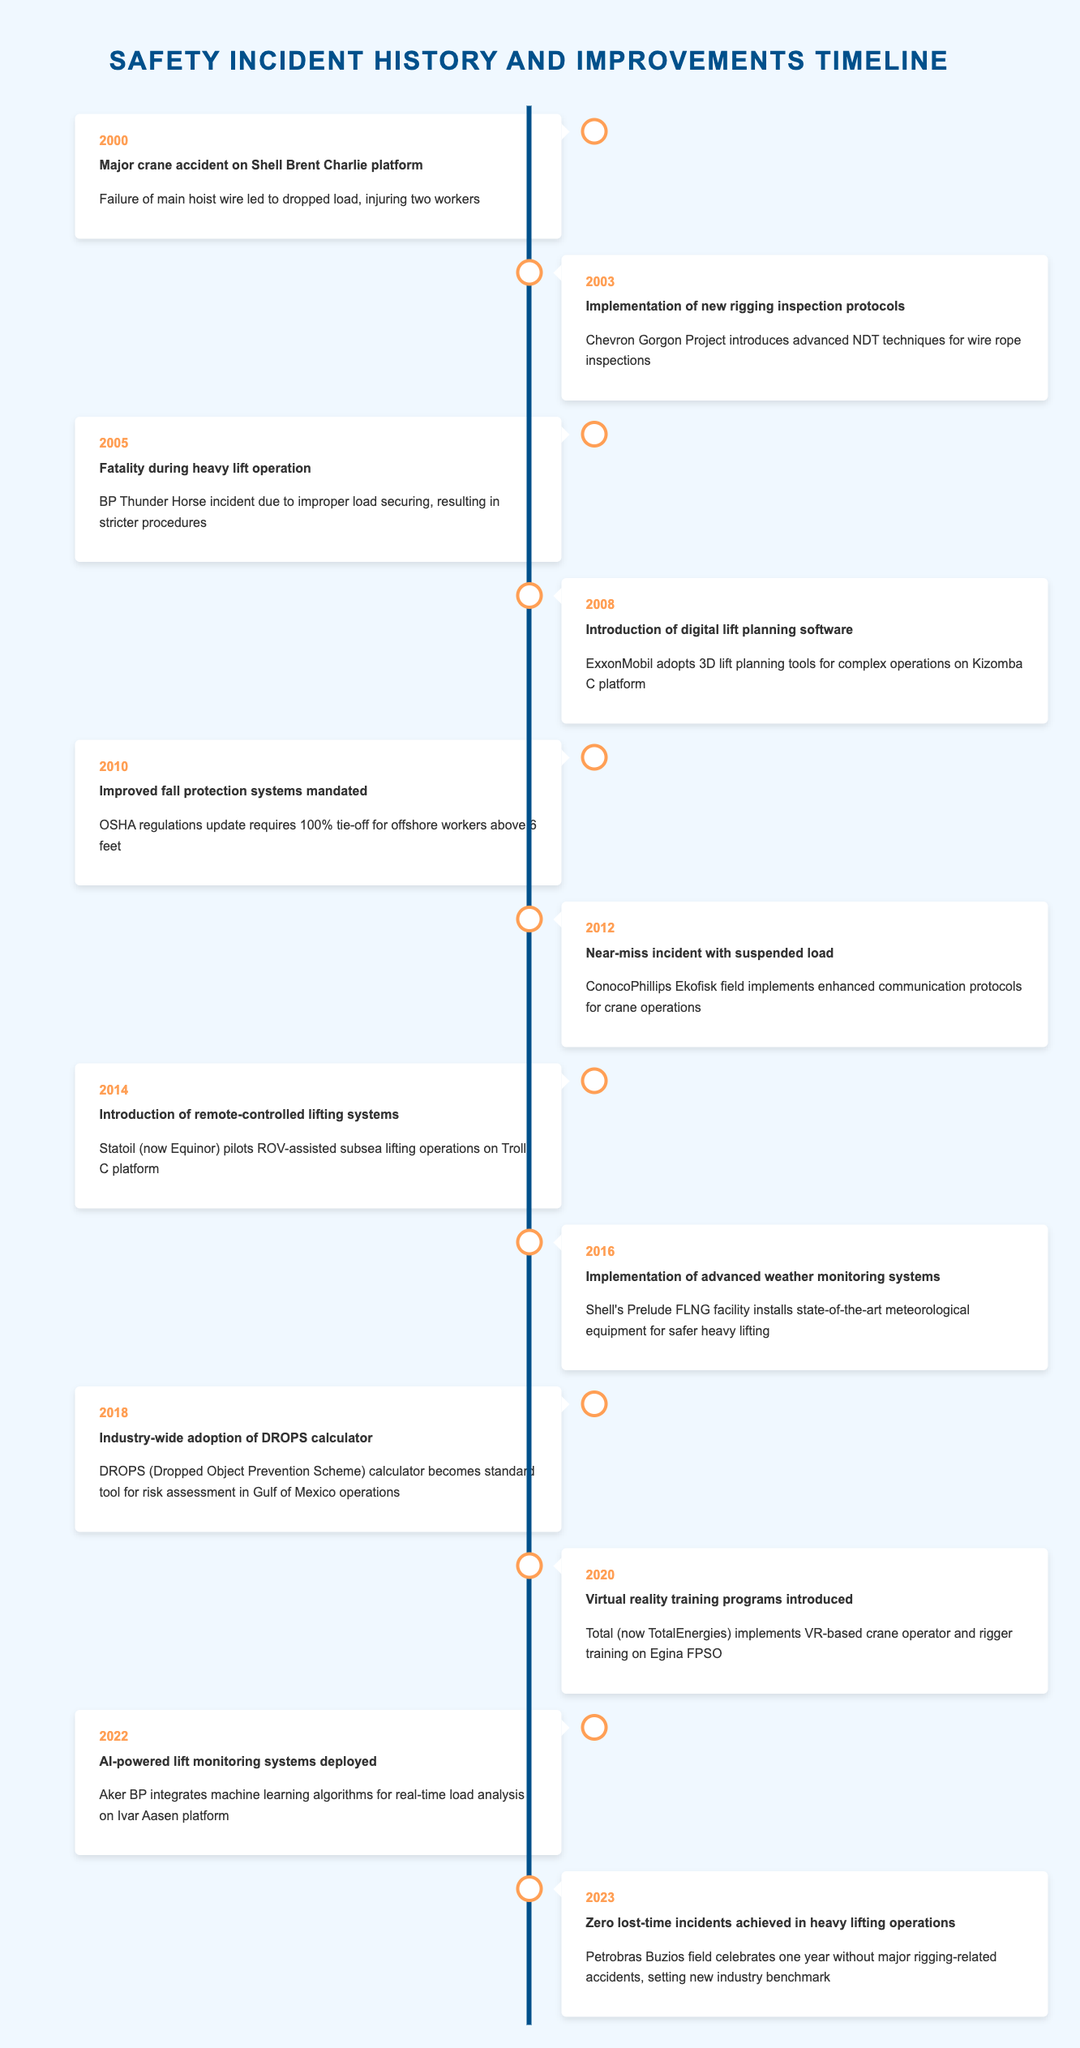What year did the major crane accident occur on the Shell Brent Charlie platform? The timeline indicates the event occurred in the year 2000, where a major crane accident was recorded on the Shell Brent Charlie platform.
Answer: 2000 What improvement was made in 2003 regarding rigging inspections? In 2003, the Chevron Gorgon Project introduced advanced non-destructive testing techniques for wire rope inspections, as per the timeline data provided.
Answer: Advanced NDT techniques for wire rope inspections How many incidents related to heavy lifting resulted in fatalities from 2000 to 2023? Reviewing the timeline data, there are two specific incidents with fatalities due to heavy lifting operations: the major crane accident in 2000 and the fatality during the BP Thunder Horse incident in 2005, totaling 2 incidents.
Answer: 2 Did the year 2018 see the introduction of new technology related to dropped object prevention? The timeline shows that in 2018, there was indeed an industry-wide adoption of a DROPS calculator, aimed at risk assessment related to dropped objects.
Answer: Yes What were the primary safety-minded improvements made in the years immediately following 2010? Between 2010 and 2012, the improvements included mandating fall protection systems in 2010 and the implementation of enhanced communication protocols for crane operations in 2012, after reviewing the events listed in those years.
Answer: Improved fall protection systems and enhanced communication protocols What was the significant change for heavy lifting operations noted in 2023? The timeline states that in 2023, Petrobras Buzios field achieved zero lost-time incidents in heavy lifting operations, signaling a significant milestone for safety on that platform.
Answer: Zero lost-time incidents achieved In which year was the use of virtual reality training programs for rigging introduced? The timeline indicates that virtual reality training programs were introduced in 2020 by Total (now TotalEnergies) for crane operators and riggers.
Answer: 2020 What is the main technological advancement documented in 2022? In 2022, the timeline records that Aker BP deployed AI-powered lift monitoring systems, which integrated machine learning algorithms for load analysis, marking a significant technological advancement in safety protocols.
Answer: AI-powered lift monitoring systems deployed Have there been any incidents of major rigging-related accidents noted after 2020? According to the timeline, after 2020, specifically in 2023, there were no major rigging-related accidents confirmed, establishing a benchmark for safety with zero lost-time incidents.
Answer: No 